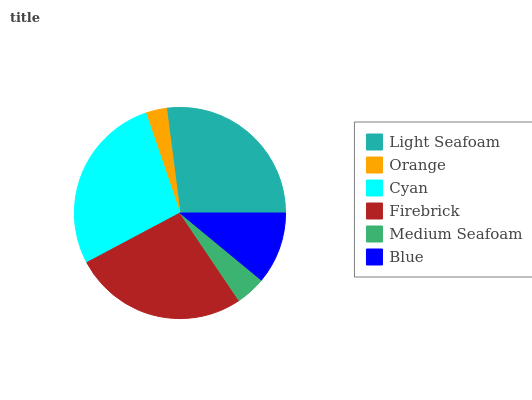Is Orange the minimum?
Answer yes or no. Yes. Is Cyan the maximum?
Answer yes or no. Yes. Is Cyan the minimum?
Answer yes or no. No. Is Orange the maximum?
Answer yes or no. No. Is Cyan greater than Orange?
Answer yes or no. Yes. Is Orange less than Cyan?
Answer yes or no. Yes. Is Orange greater than Cyan?
Answer yes or no. No. Is Cyan less than Orange?
Answer yes or no. No. Is Firebrick the high median?
Answer yes or no. Yes. Is Blue the low median?
Answer yes or no. Yes. Is Blue the high median?
Answer yes or no. No. Is Firebrick the low median?
Answer yes or no. No. 